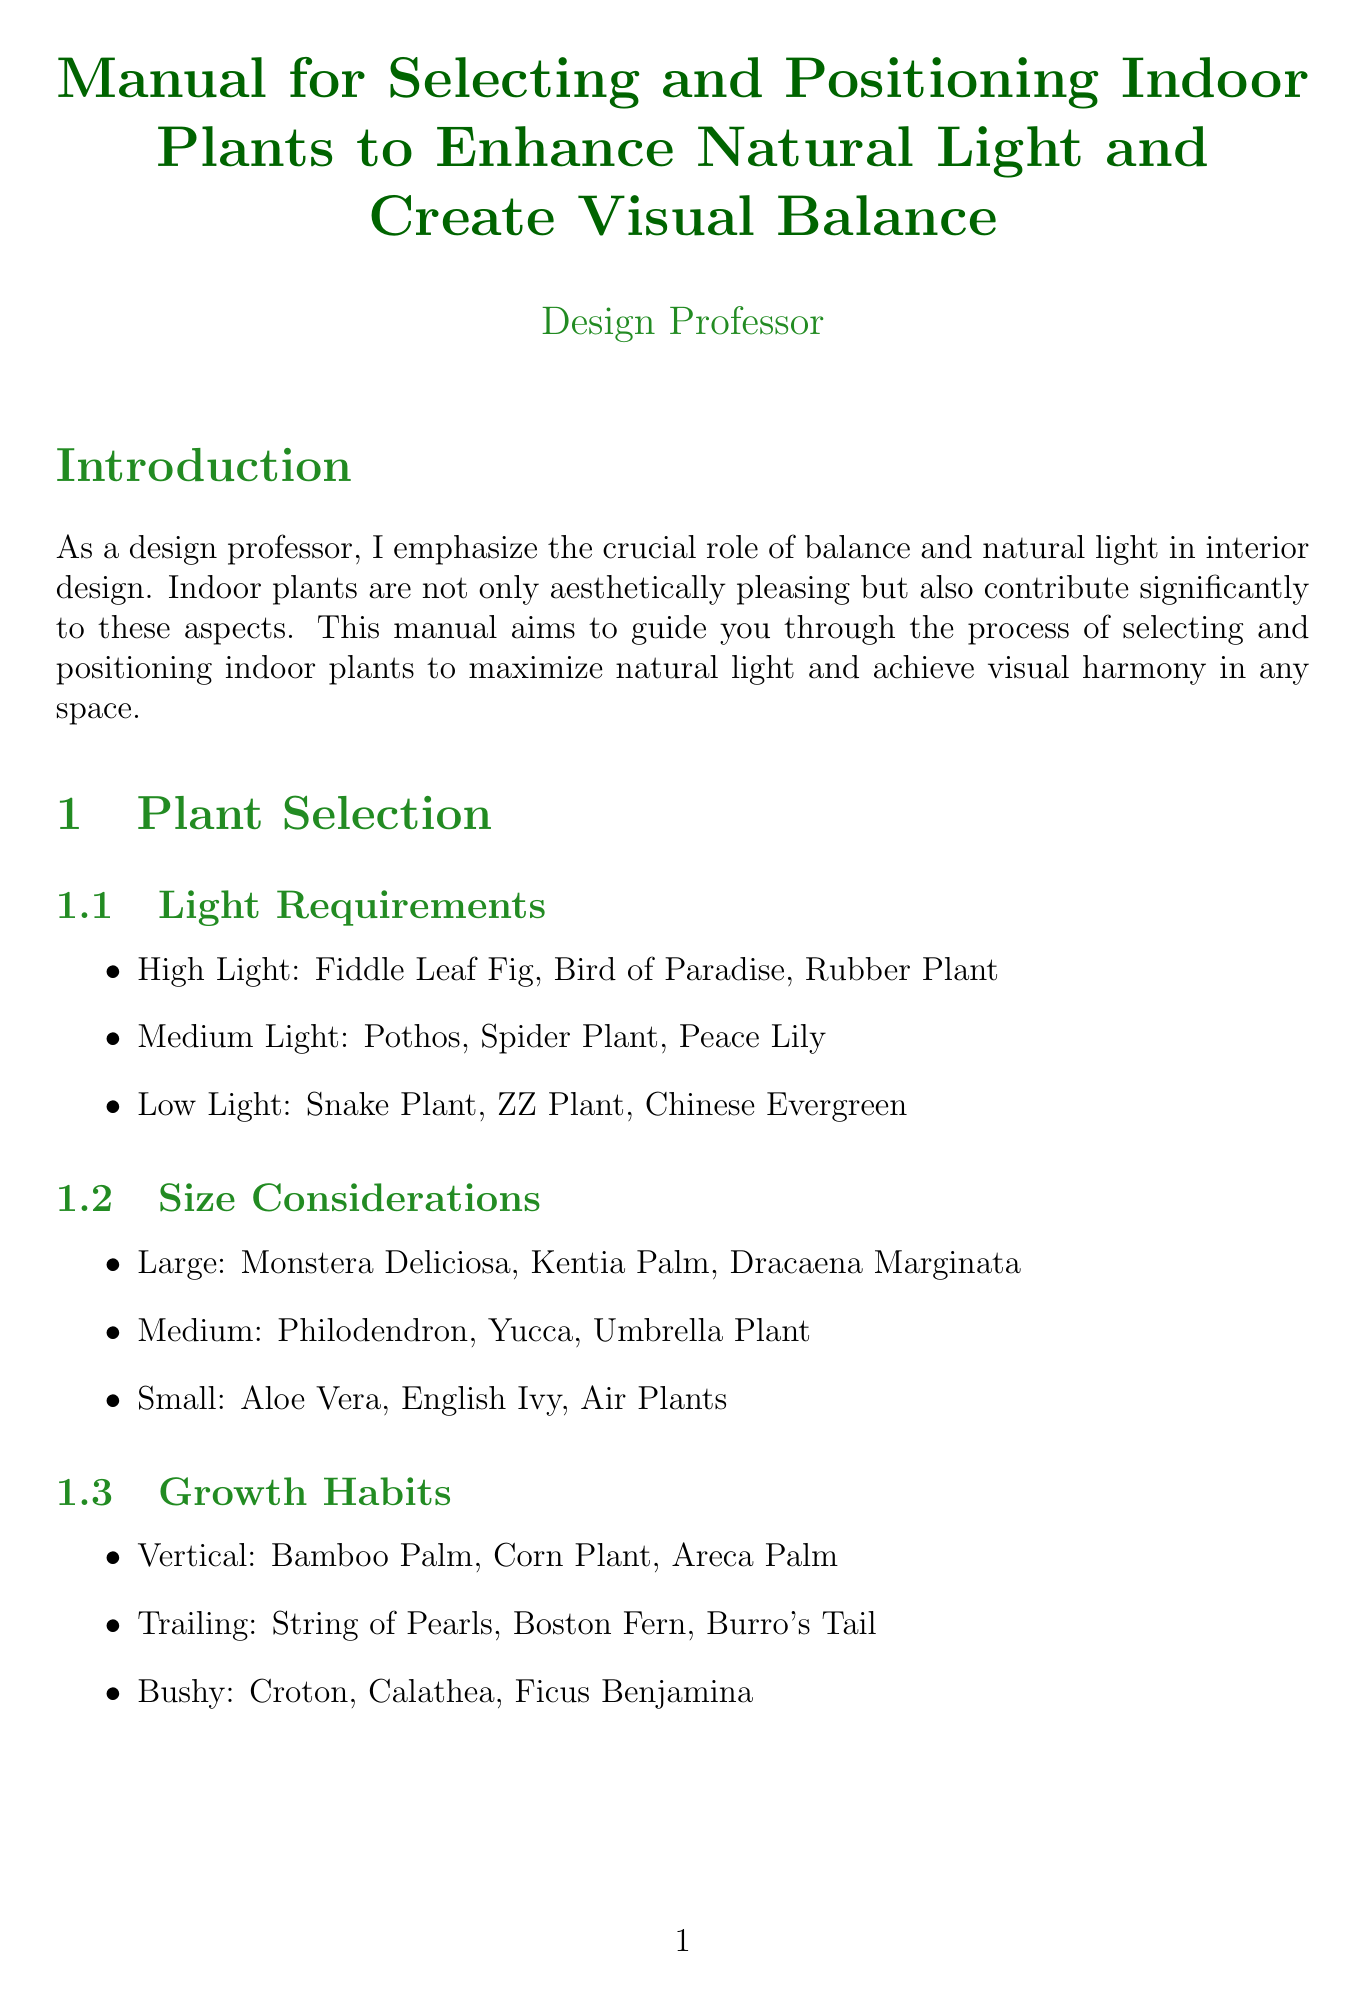what is the title of the manual? The title is explicitly stated at the beginning of the document as "Manual for Selecting and Positioning Indoor Plants to Enhance Natural Light and Create Visual Balance."
Answer: Manual for Selecting and Positioning Indoor Plants to Enhance Natural Light and Create Visual Balance which plant is suitable for high light conditions? The document lists specific plants suitable for high light conditions in the plant selection section.
Answer: Fiddle Leaf Fig how many categories does the plant selection section have? The structure of the plant selection section indicates various subcategories, and the document lists three specific categories.
Answer: Three what is one technique mentioned for enhancing light? The light enhancement techniques section consists of specific strategies aimed at maximizing light for indoor plants.
Answer: Use mirrors or metallic accents near plants to bounce light what is the recommended position for high-light plants? The positioning strategies section informs about plant placement based on their light requirements.
Answer: Place high-light plants closest to windows name one way to create visual balance according to the document. The document outlines specific methods for achieving visual balance throughout its dedicated section.
Answer: Place matching plants on either side of a focal point which case study focuses on limited natural light? The case studies section presents different challenges and solutions, specifically highlighting certain cases.
Answer: North-facing bedroom list one maintenance tip provided in the manual. The maintenance tips section includes actionable suggestions for the upkeep of indoor plants.
Answer: Regularly rotate plants to ensure even light exposure and growth 